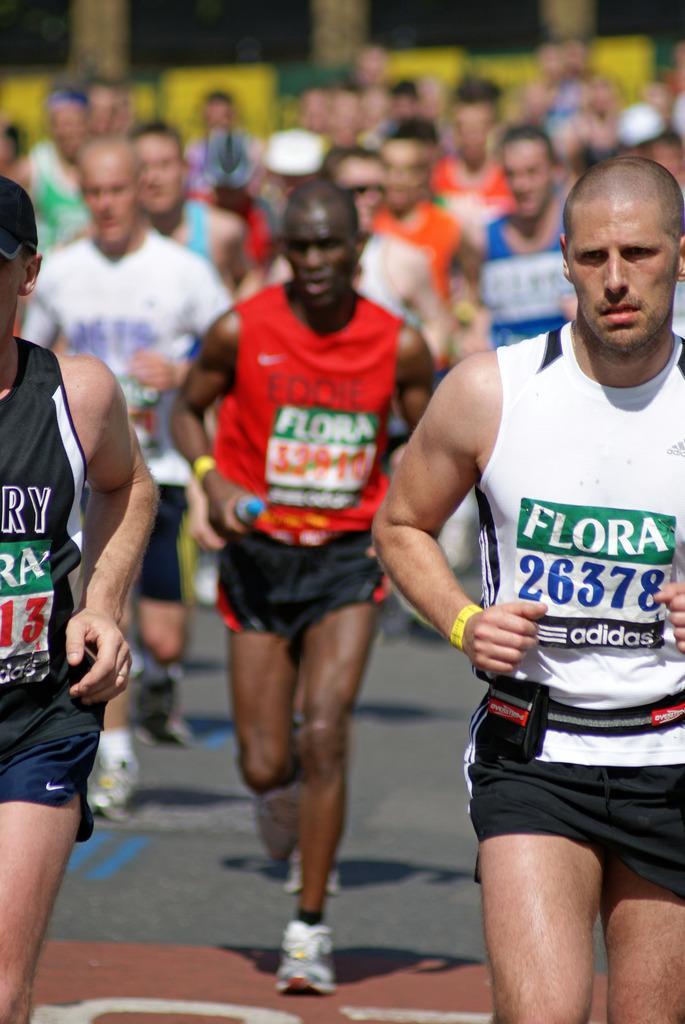<image>
Share a concise interpretation of the image provided. People are running in a marathon and their numbers are sponsored by Flora and Adidas. 